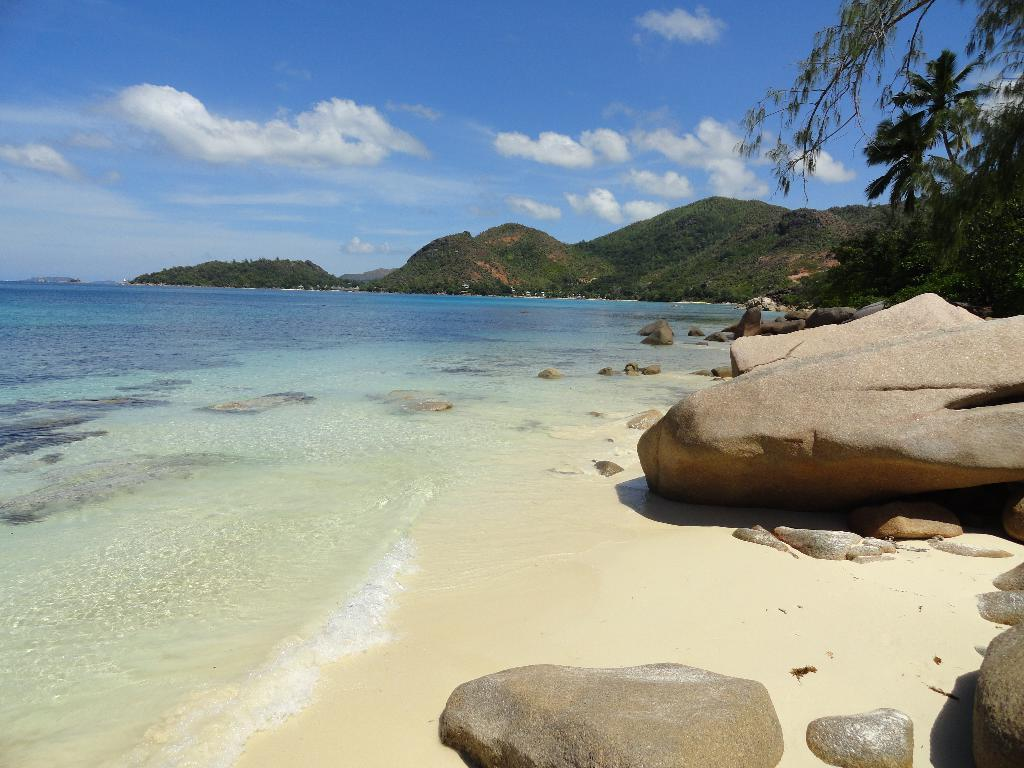What is one of the natural elements present in the image? There is water in the image. What type of vegetation can be seen in the image? There are trees in the image. What type of terrain is visible in the image? There are stones in the image, and a hill is visible in the background. What can be seen in the sky in the image? The sky is visible in the background of the image, and clouds are present. What type of poison is being used to treat the trees in the image? There is no indication of any poison being used to treat the trees in the image; they appear to be healthy. 